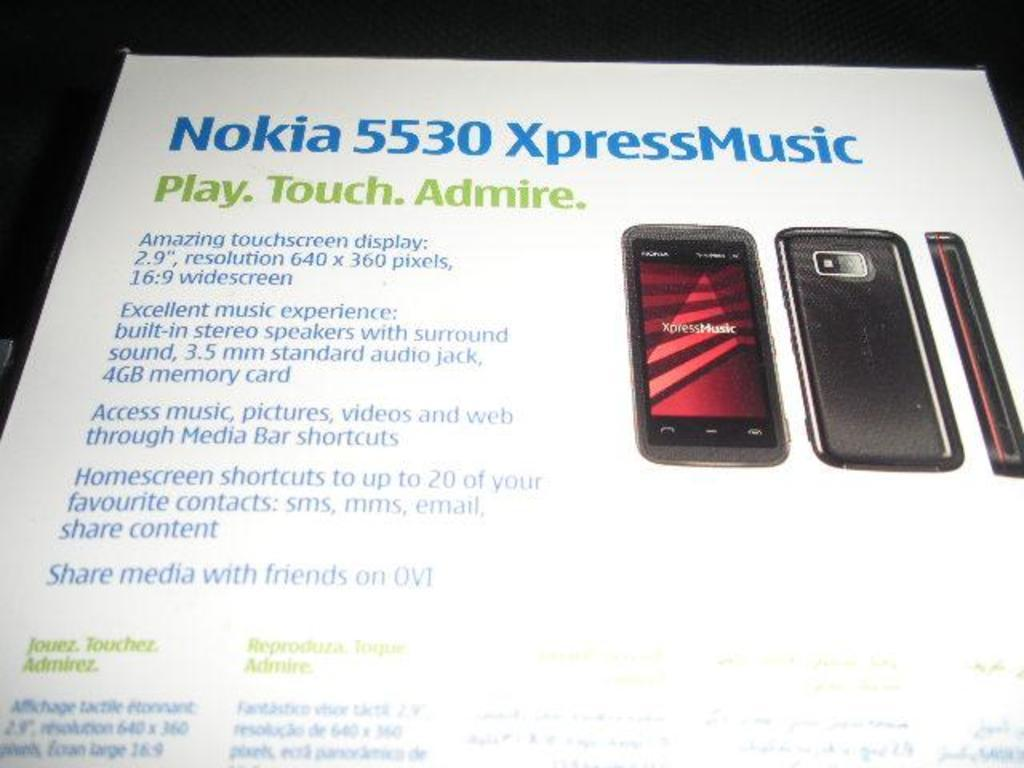<image>
Share a concise interpretation of the image provided. a white paper that is titled 'nokia 5530 xpressmusic' 